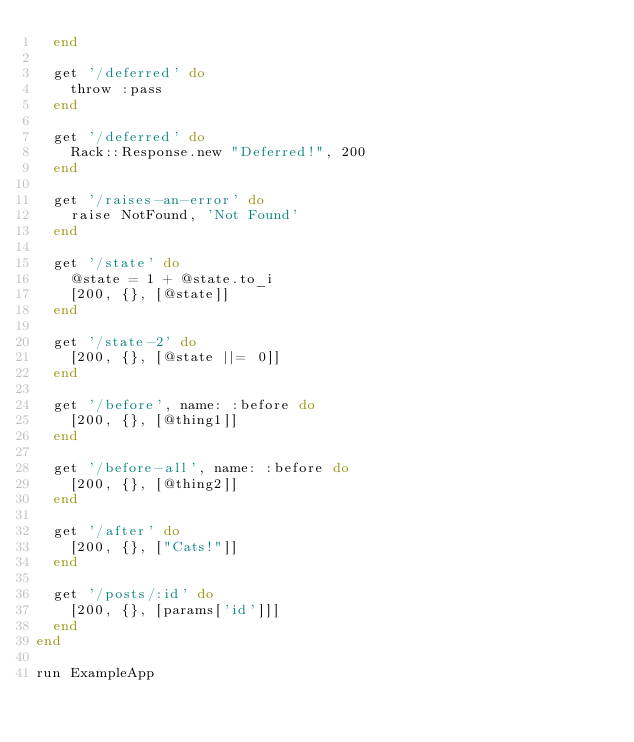<code> <loc_0><loc_0><loc_500><loc_500><_Ruby_>  end

  get '/deferred' do
    throw :pass
  end

  get '/deferred' do
    Rack::Response.new "Deferred!", 200
  end

  get '/raises-an-error' do
    raise NotFound, 'Not Found'
  end

  get '/state' do
    @state = 1 + @state.to_i
    [200, {}, [@state]]
  end

  get '/state-2' do
    [200, {}, [@state ||= 0]]
  end

  get '/before', name: :before do
    [200, {}, [@thing1]]
  end

  get '/before-all', name: :before do
    [200, {}, [@thing2]]
  end

  get '/after' do
    [200, {}, ["Cats!"]]
  end

  get '/posts/:id' do
    [200, {}, [params['id']]]
  end
end

run ExampleApp
</code> 